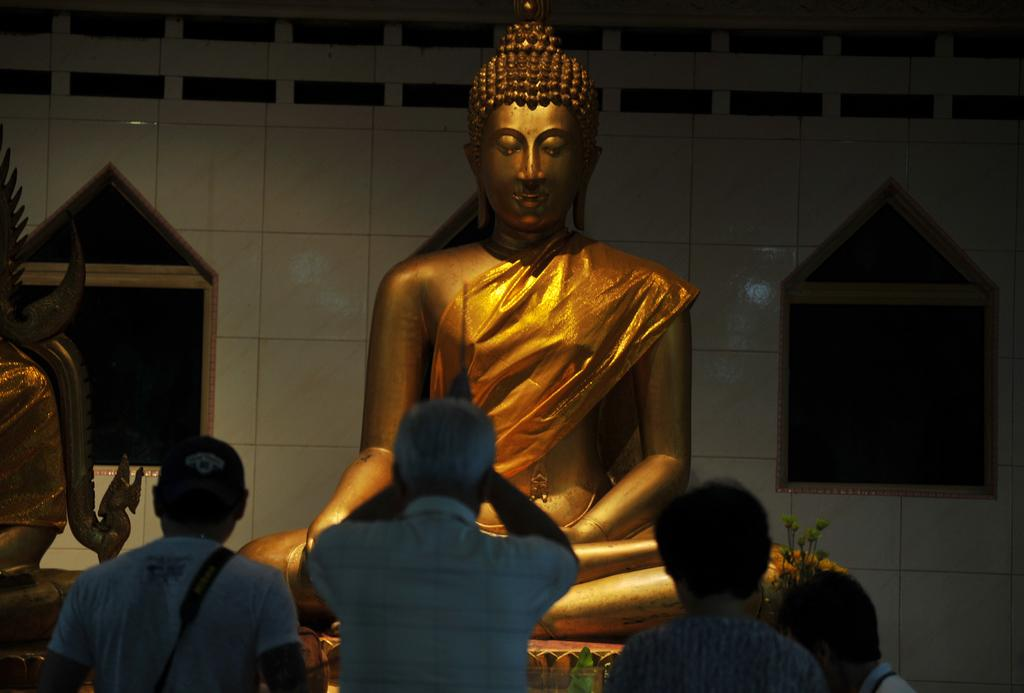What can be seen in the image that represents artistic creations? There are statues in the image. Who is present at the bottom of the image? There are people at the bottom of the image. What type of wall can be seen in the background of the image? There is a tile wall in the background of the image. What type of plants are visible in the image? Flowers are present in the image. What other objects can be seen in the image besides statues and flowers? There are other objects visible in the image. How many brothers are present in the image? There is no mention of a brother or any siblings in the image. What type of currency can be seen in the image? There is no mention of any currency, such as quarters, in the image. 